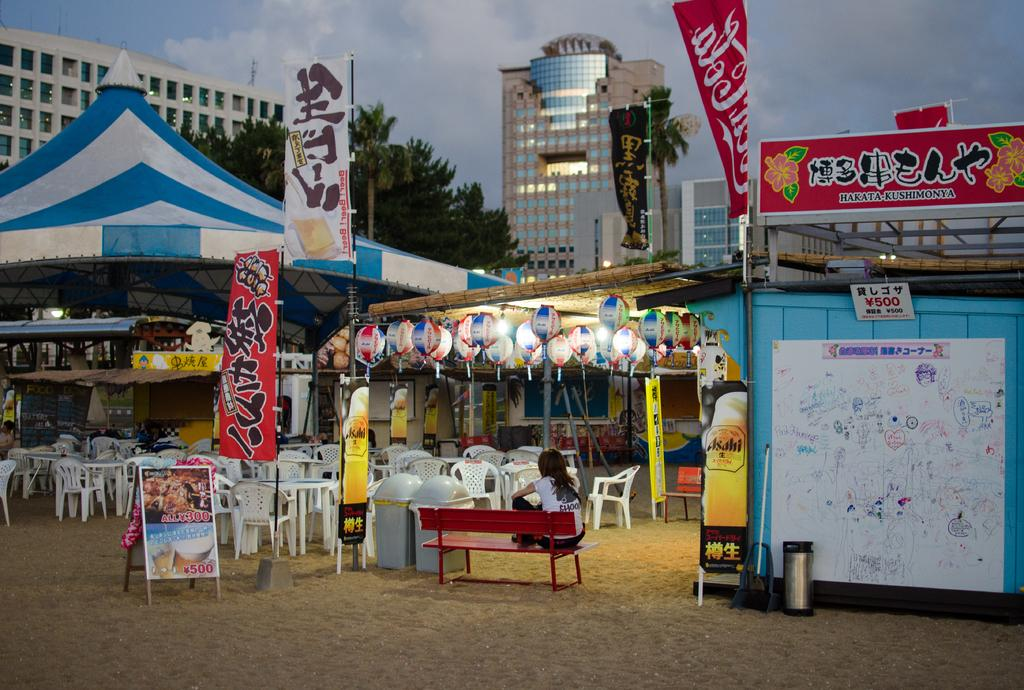What is the person in the image doing? The person is sitting on a bench in the image. What type of furniture is present in the image besides the bench? There are chairs and tables in the image. What other objects can be seen in the image? There is a board, a banner, and a tent. What type of structures are visible in the image? There are buildings in the image. What type of natural elements are present in the image? There are trees and the sky is visible. What can be seen in the sky? There are clouds in the sky. How many pies are stacked on the board in the image? There are no pies present in the image. What type of stick is being used to hold up the banner in the image? There is no stick visible in the image; the banner is not being held up by any visible support. 